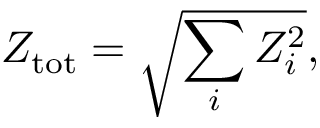Convert formula to latex. <formula><loc_0><loc_0><loc_500><loc_500>Z _ { t o t } = \sqrt { \sum _ { i } Z _ { i } ^ { 2 } } ,</formula> 